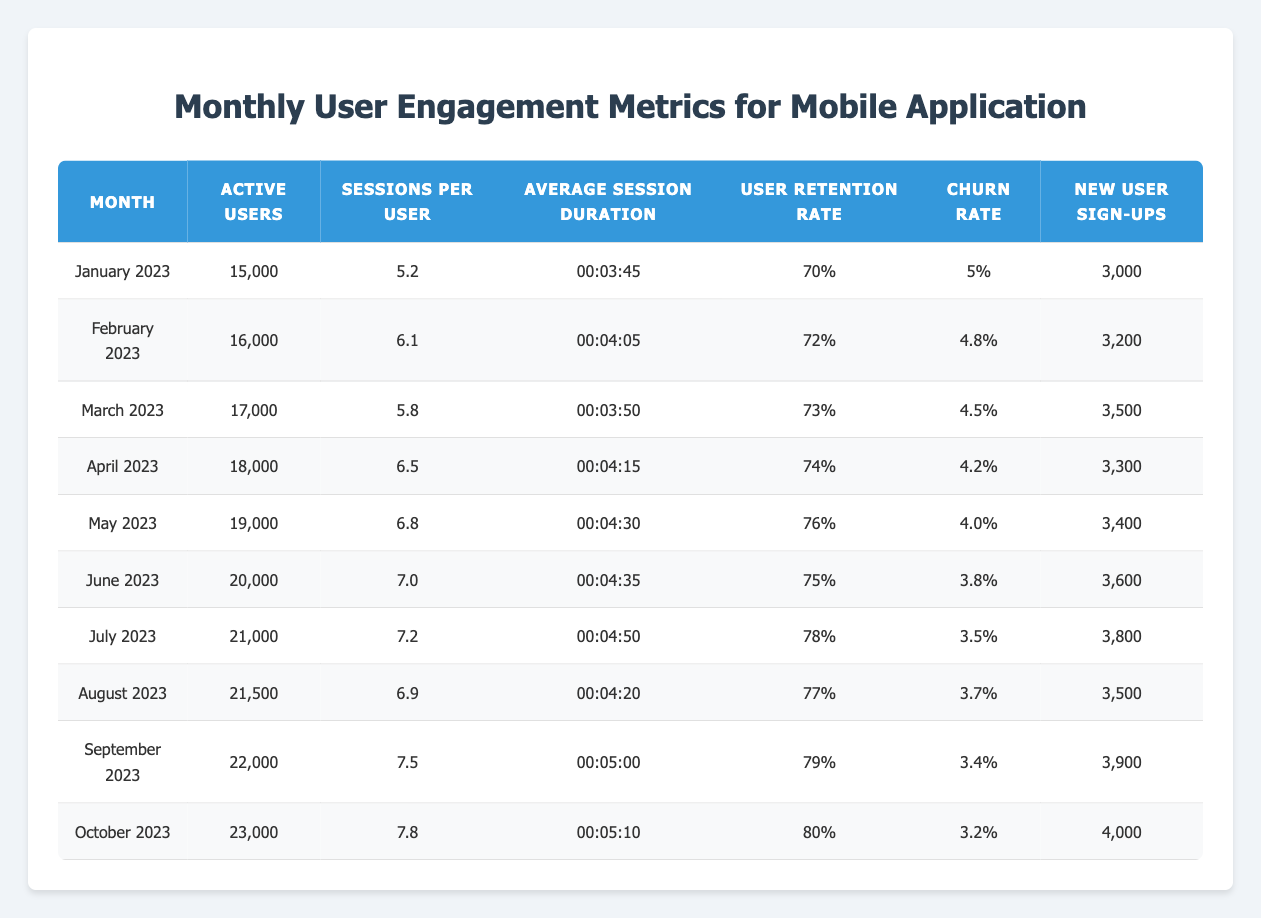What was the average number of active users from January to October 2023? To find the average number of active users, we sum the active users for each month: 15,000 + 16,000 + 17,000 + 18,000 + 19,000 + 20,000 + 21,000 + 21,500 + 22,000 + 23,000 =  192,500. Then we divide by the number of months, which is 10: 192,500 / 10 = 19,250.
Answer: 19,250 What was the user retention rate in October 2023? The user retention rate for October 2023 is explicitly stated in the table as 80%.
Answer: 80% In which month did the highest churn rate occur? The churn rate for each month is listed in the table. Checking each value, the highest churn rate is 5% in January 2023.
Answer: January 2023 What percentage increase in active users was observed from April to October 2023? To find the percentage increase in active users, we calculate the difference in active users between October (23,000) and April (18,000), which is 23,000 - 18,000 = 5,000. We then divide this by the number of active users in April and multiply by 100: (5,000 / 18,000) * 100 = 27.78%.
Answer: 27.78% Did the average session duration increase from January to October 2023? In January, the average session duration is 00:03:45, and in October, it is 00:05:10. Since 00:05:10 is greater than 00:03:45, we can conclude that the average session duration increased.
Answer: Yes What was the total number of new user sign-ups from January to October 2023? The total new user sign-ups can be found by summing the monthly sign-ups: 3,000 + 3,200 + 3,500 + 3,300 + 3,400 + 3,600 + 3,800 + 3,500 + 3,900 + 4,000 = 35,400.
Answer: 35,400 How many sessions per user were recorded in June 2023? The sessions per user for June 2023 is clearly indicated in the table as 7.0.
Answer: 7.0 What is the trend in the churn rate from January to October 2023? Observing the churn rates from the table, we see they decreased from 5% in January to 3.2% in October, indicating a downward trend.
Answer: Downward trend Which month had the lowest number of new user sign-ups compared to others? By examining the new user sign-ups for each month, January had the lowest at 3,000.
Answer: January What was the increase in sessions per user from March to July 2023? The sessions per user in March 2023 are 5.8, and in July 2023 it is 7.2. Therefore, the increase is 7.2 - 5.8 = 1.4.
Answer: 1.4 Was the user retention rate higher in August or September 2023? The user retention rates are 77% for August and 79% for September. Since 79% is greater than 77%, the retention rate was higher in September.
Answer: September 2023 